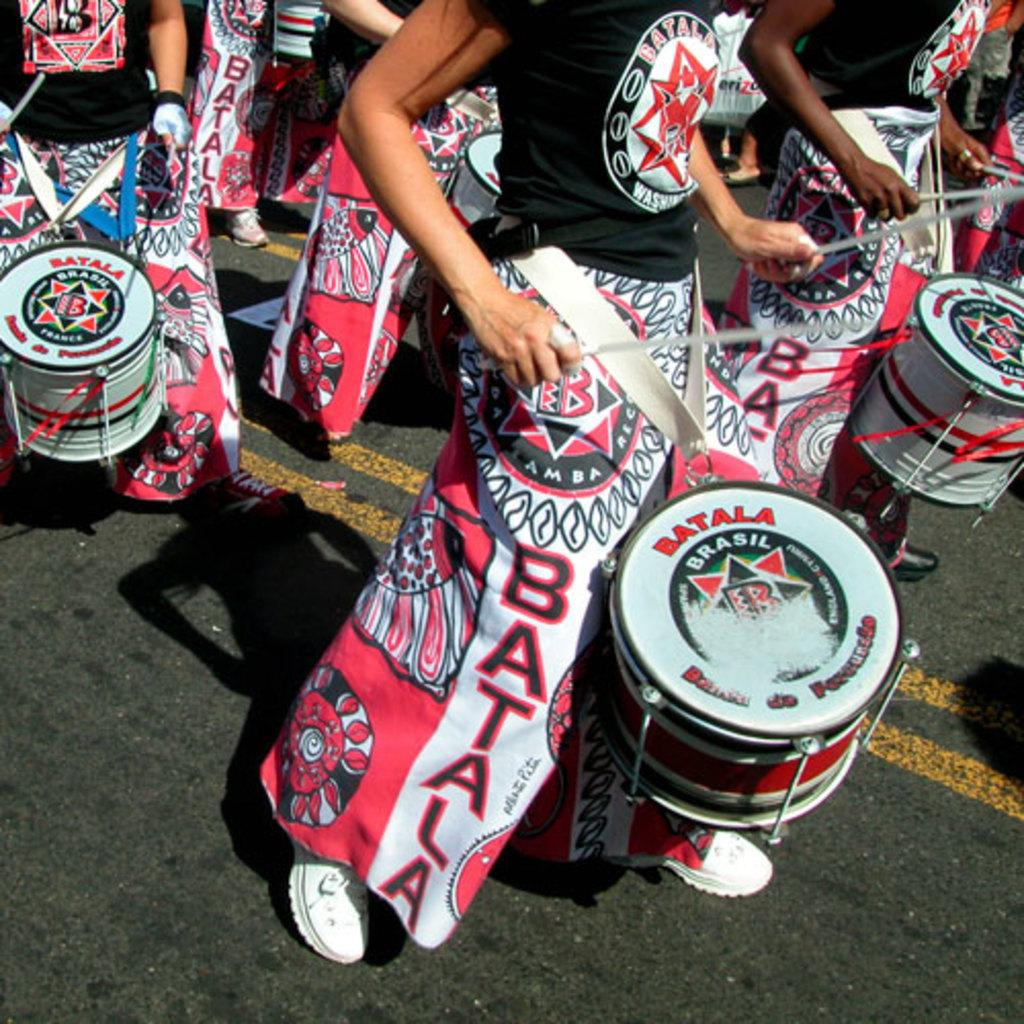Provide a one-sentence caption for the provided image. People wearing pink and black clothing with the word Batala on it beating Batala drums march down the street. 